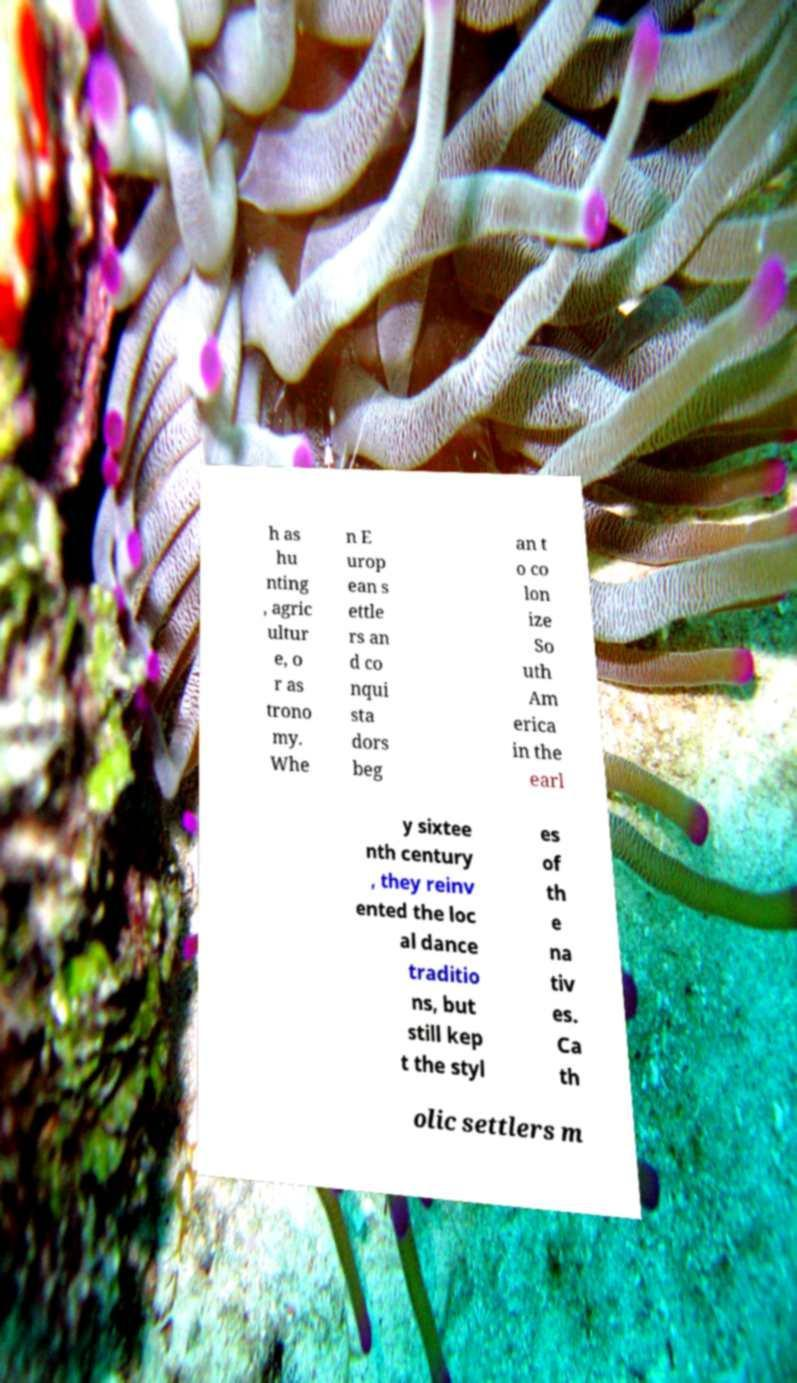Could you extract and type out the text from this image? h as hu nting , agric ultur e, o r as trono my. Whe n E urop ean s ettle rs an d co nqui sta dors beg an t o co lon ize So uth Am erica in the earl y sixtee nth century , they reinv ented the loc al dance traditio ns, but still kep t the styl es of th e na tiv es. Ca th olic settlers m 